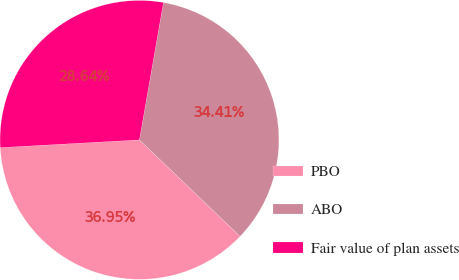Convert chart. <chart><loc_0><loc_0><loc_500><loc_500><pie_chart><fcel>PBO<fcel>ABO<fcel>Fair value of plan assets<nl><fcel>36.95%<fcel>34.41%<fcel>28.64%<nl></chart> 